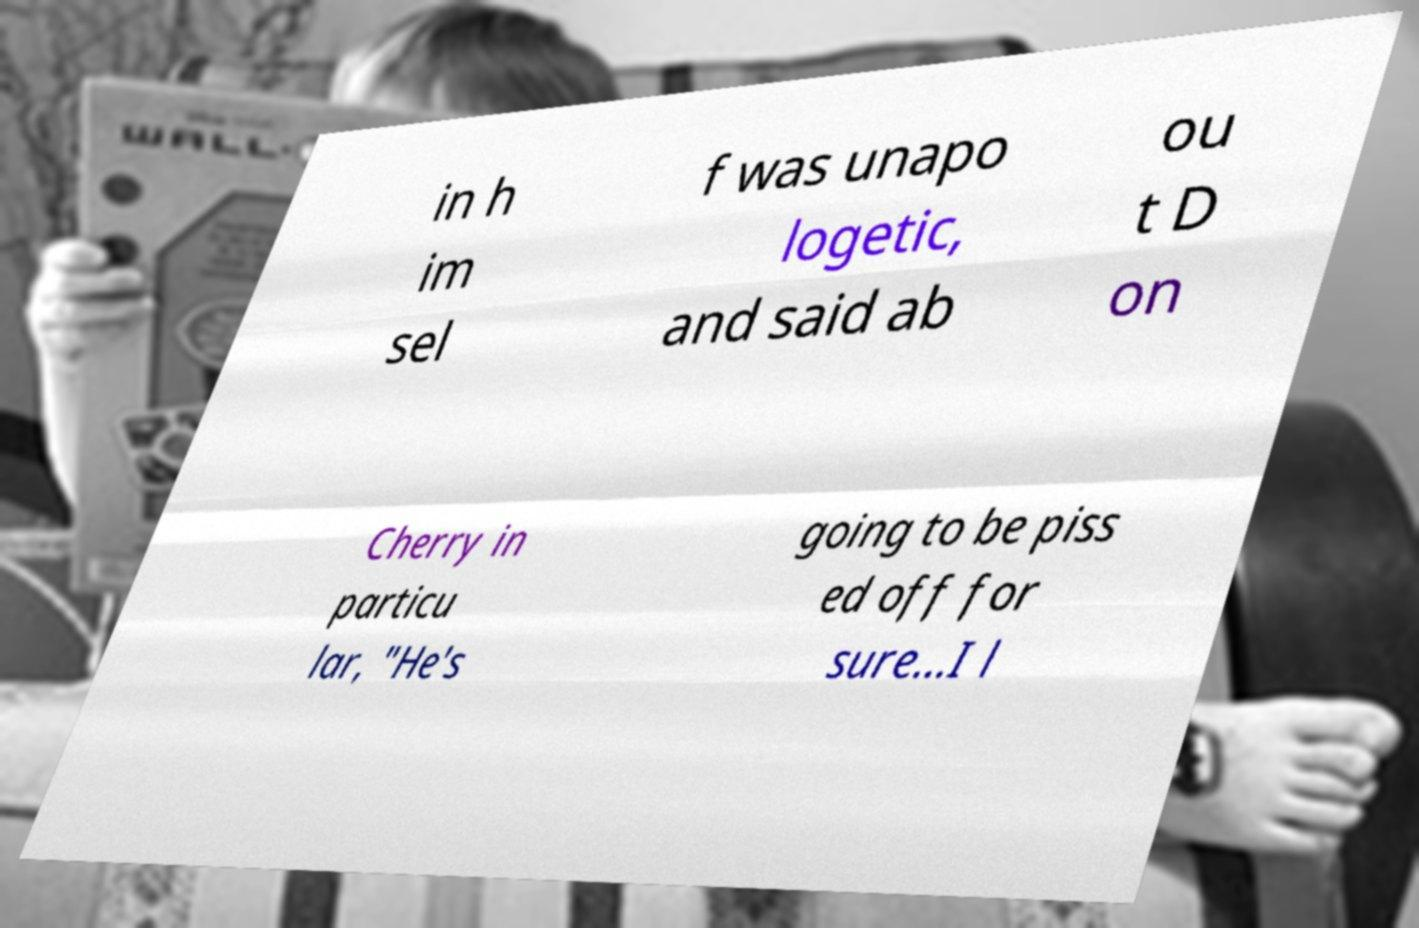Please read and relay the text visible in this image. What does it say? in h im sel f was unapo logetic, and said ab ou t D on Cherry in particu lar, "He's going to be piss ed off for sure...I l 